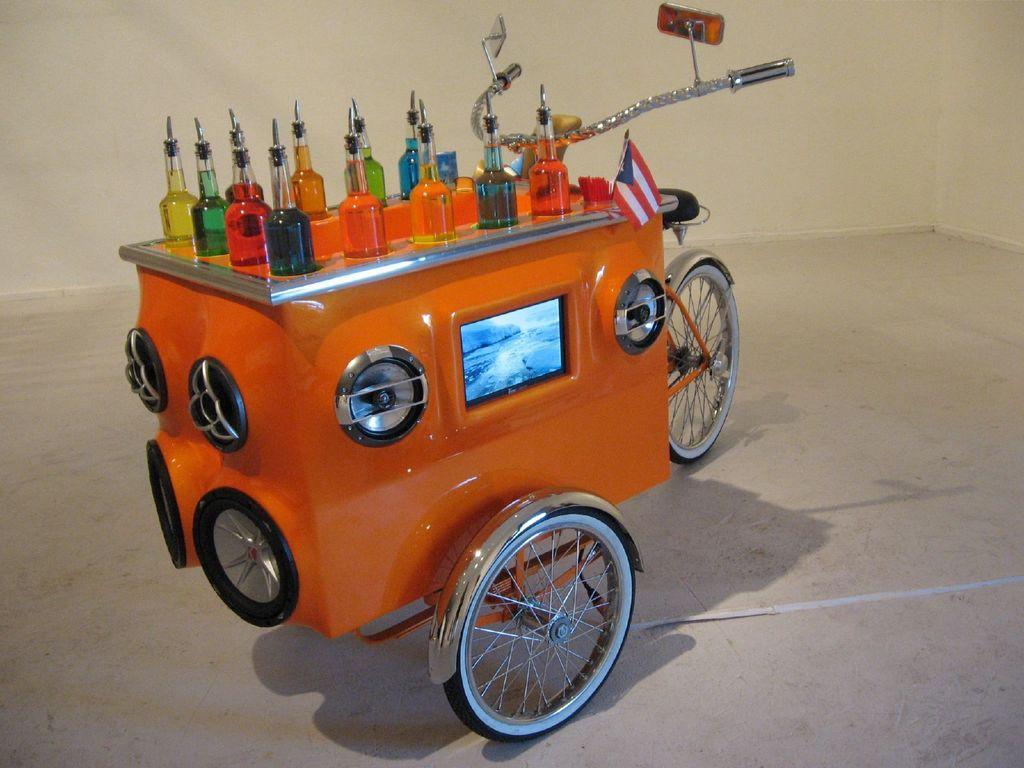In one or two sentences, can you explain what this image depicts? In this image we can see a cart with bottles. At the bottom of the image there is floor. In the background of the image there is wall. 